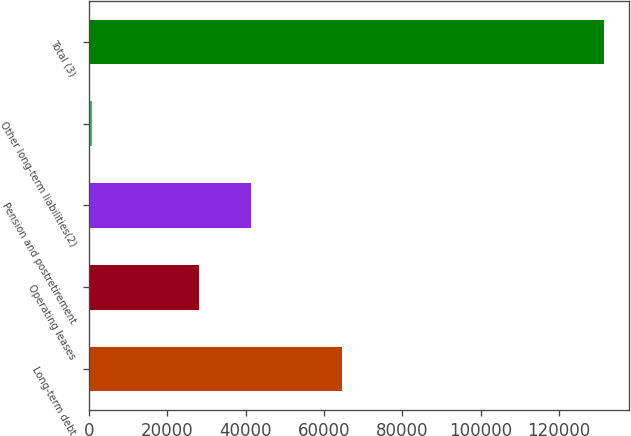Convert chart. <chart><loc_0><loc_0><loc_500><loc_500><bar_chart><fcel>Long-term debt<fcel>Operating leases<fcel>Pension and postretirement<fcel>Other long-term liabilities(2)<fcel>Total (3)<nl><fcel>64623<fcel>28192<fcel>41266.8<fcel>678<fcel>131426<nl></chart> 